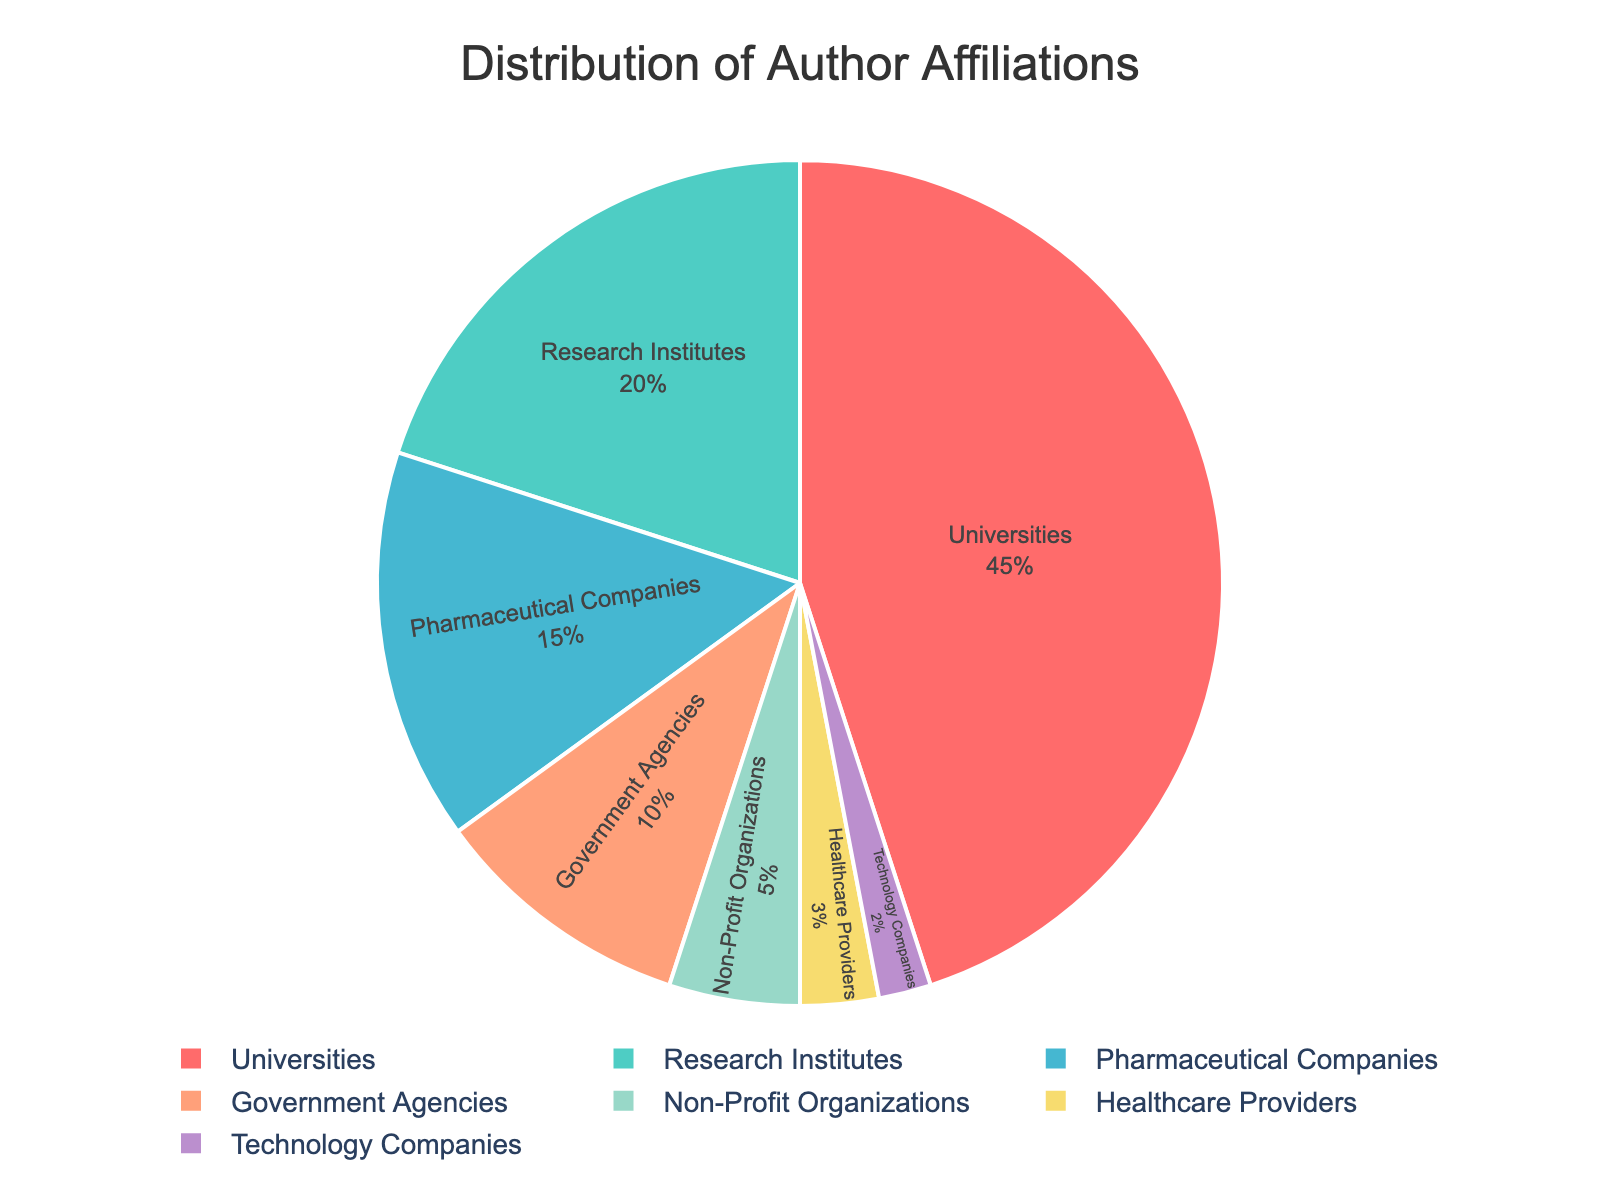Which affiliation has the highest percentage? By observing the pie chart, the affiliation with the highest percentage occupies the largest segment of the chart. In this case, Universities take up 45% of the chart.
Answer: Universities Which two affiliations combined have a 30% share? By identifying the affiliations with their respective percentages, we see that Research Institutes at 20% and Pharmaceutical Companies at 15% are the closest sum to 30%. However, adding the 10% from Government Agencies with the 20% from Research Institutes gives exactly 30%.
Answer: Research Institutes and Government Agencies How does the percentage of Government Agencies compare to that of Non-Profit Organizations? Comparing the two segments, Government Agencies have a 10% segment, whereas Non-Profit Organizations have a smaller segment at 5%. Thus, Government Agencies have a higher percentage than Non-Profit Organizations.
Answer: Government Agencies have a higher percentage What is the total percentage of affiliations not related to universities and research institutes? Adding the percentages of all affiliations excluding Universities (45%) and Research Institutes (20%): 15% (Pharmaceutical Companies) + 10% (Government Agencies) + 5% (Non-Profit Organizations) + 3% (Healthcare Providers) + 2% (Technology Companies) = 35%.
Answer: 35% Which segment is colored in red and what percentage does it represent? Referring to the color scheme in the pie chart, red typically is the first color in custom color palettes. The segment in red represents Universities with 45%.
Answer: Universities, 45% Is the percentage share of Healthcare Providers greater than Technology Companies? By observing the respective segments, Healthcare Providers have a 3% share, while Technology Companies have a 2% share. Therefore, Healthcare Providers have a greater percentage.
Answer: Yes What is the difference in percentage between the largest and smallest segments? The largest segment is Universities with 45%, and the smallest is Technology Companies with 2%. The difference is calculated as 45% - 2% = 43%.
Answer: 43% How much greater is the percentage share of Pharmaceutical Companies compared to Non-Profit Organizations? Pharmaceutical Companies have a 15% share, whereas Non-Profit Organizations have 5%. The difference is calculated as 15% - 5% = 10%.
Answer: 10% What is the combined percentage of affiliations related to the government (Government Agencies and Non-Profit Organizations)? Adding the percentages of Government Agencies (10%) and Non-Profit Organizations (5%) results in 10% + 5% = 15%.
Answer: 15% What percentage of the affiliations is accounted for by academic institutions? Academic institutions refer to Universities and Research Institutes. Adding their percentages: 45% (Universities) + 20% (Research Institutes) = 65%.
Answer: 65% 